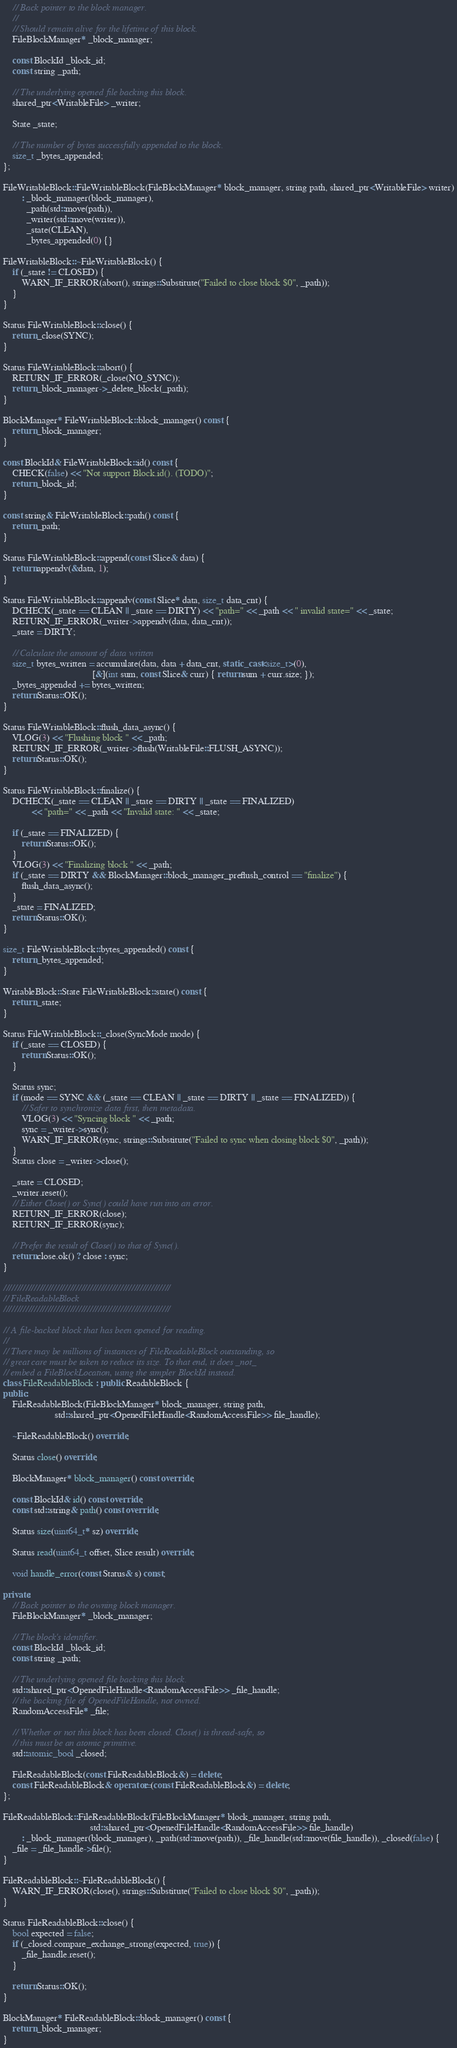<code> <loc_0><loc_0><loc_500><loc_500><_C++_>    // Back pointer to the block manager.
    //
    // Should remain alive for the lifetime of this block.
    FileBlockManager* _block_manager;

    const BlockId _block_id;
    const string _path;

    // The underlying opened file backing this block.
    shared_ptr<WritableFile> _writer;

    State _state;

    // The number of bytes successfully appended to the block.
    size_t _bytes_appended;
};

FileWritableBlock::FileWritableBlock(FileBlockManager* block_manager, string path, shared_ptr<WritableFile> writer)
        : _block_manager(block_manager),
          _path(std::move(path)),
          _writer(std::move(writer)),
          _state(CLEAN),
          _bytes_appended(0) {}

FileWritableBlock::~FileWritableBlock() {
    if (_state != CLOSED) {
        WARN_IF_ERROR(abort(), strings::Substitute("Failed to close block $0", _path));
    }
}

Status FileWritableBlock::close() {
    return _close(SYNC);
}

Status FileWritableBlock::abort() {
    RETURN_IF_ERROR(_close(NO_SYNC));
    return _block_manager->_delete_block(_path);
}

BlockManager* FileWritableBlock::block_manager() const {
    return _block_manager;
}

const BlockId& FileWritableBlock::id() const {
    CHECK(false) << "Not support Block.id(). (TODO)";
    return _block_id;
}

const string& FileWritableBlock::path() const {
    return _path;
}

Status FileWritableBlock::append(const Slice& data) {
    return appendv(&data, 1);
}

Status FileWritableBlock::appendv(const Slice* data, size_t data_cnt) {
    DCHECK(_state == CLEAN || _state == DIRTY) << "path=" << _path << " invalid state=" << _state;
    RETURN_IF_ERROR(_writer->appendv(data, data_cnt));
    _state = DIRTY;

    // Calculate the amount of data written
    size_t bytes_written = accumulate(data, data + data_cnt, static_cast<size_t>(0),
                                      [&](int sum, const Slice& curr) { return sum + curr.size; });
    _bytes_appended += bytes_written;
    return Status::OK();
}

Status FileWritableBlock::flush_data_async() {
    VLOG(3) << "Flushing block " << _path;
    RETURN_IF_ERROR(_writer->flush(WritableFile::FLUSH_ASYNC));
    return Status::OK();
}

Status FileWritableBlock::finalize() {
    DCHECK(_state == CLEAN || _state == DIRTY || _state == FINALIZED)
            << "path=" << _path << "Invalid state: " << _state;

    if (_state == FINALIZED) {
        return Status::OK();
    }
    VLOG(3) << "Finalizing block " << _path;
    if (_state == DIRTY && BlockManager::block_manager_preflush_control == "finalize") {
        flush_data_async();
    }
    _state = FINALIZED;
    return Status::OK();
}

size_t FileWritableBlock::bytes_appended() const {
    return _bytes_appended;
}

WritableBlock::State FileWritableBlock::state() const {
    return _state;
}

Status FileWritableBlock::_close(SyncMode mode) {
    if (_state == CLOSED) {
        return Status::OK();
    }

    Status sync;
    if (mode == SYNC && (_state == CLEAN || _state == DIRTY || _state == FINALIZED)) {
        // Safer to synchronize data first, then metadata.
        VLOG(3) << "Syncing block " << _path;
        sync = _writer->sync();
        WARN_IF_ERROR(sync, strings::Substitute("Failed to sync when closing block $0", _path));
    }
    Status close = _writer->close();

    _state = CLOSED;
    _writer.reset();
    // Either Close() or Sync() could have run into an error.
    RETURN_IF_ERROR(close);
    RETURN_IF_ERROR(sync);

    // Prefer the result of Close() to that of Sync().
    return close.ok() ? close : sync;
}

////////////////////////////////////////////////////////////
// FileReadableBlock
////////////////////////////////////////////////////////////

// A file-backed block that has been opened for reading.
//
// There may be millions of instances of FileReadableBlock outstanding, so
// great care must be taken to reduce its size. To that end, it does _not_
// embed a FileBlockLocation, using the simpler BlockId instead.
class FileReadableBlock : public ReadableBlock {
public:
    FileReadableBlock(FileBlockManager* block_manager, string path,
                      std::shared_ptr<OpenedFileHandle<RandomAccessFile>> file_handle);

    ~FileReadableBlock() override;

    Status close() override;

    BlockManager* block_manager() const override;

    const BlockId& id() const override;
    const std::string& path() const override;

    Status size(uint64_t* sz) override;

    Status read(uint64_t offset, Slice result) override;

    void handle_error(const Status& s) const;

private:
    // Back pointer to the owning block manager.
    FileBlockManager* _block_manager;

    // The block's identifier.
    const BlockId _block_id;
    const string _path;

    // The underlying opened file backing this block.
    std::shared_ptr<OpenedFileHandle<RandomAccessFile>> _file_handle;
    // the backing file of OpenedFileHandle, not owned.
    RandomAccessFile* _file;

    // Whether or not this block has been closed. Close() is thread-safe, so
    // this must be an atomic primitive.
    std::atomic_bool _closed;

    FileReadableBlock(const FileReadableBlock&) = delete;
    const FileReadableBlock& operator=(const FileReadableBlock&) = delete;
};

FileReadableBlock::FileReadableBlock(FileBlockManager* block_manager, string path,
                                     std::shared_ptr<OpenedFileHandle<RandomAccessFile>> file_handle)
        : _block_manager(block_manager), _path(std::move(path)), _file_handle(std::move(file_handle)), _closed(false) {
    _file = _file_handle->file();
}

FileReadableBlock::~FileReadableBlock() {
    WARN_IF_ERROR(close(), strings::Substitute("Failed to close block $0", _path));
}

Status FileReadableBlock::close() {
    bool expected = false;
    if (_closed.compare_exchange_strong(expected, true)) {
        _file_handle.reset();
    }

    return Status::OK();
}

BlockManager* FileReadableBlock::block_manager() const {
    return _block_manager;
}
</code> 